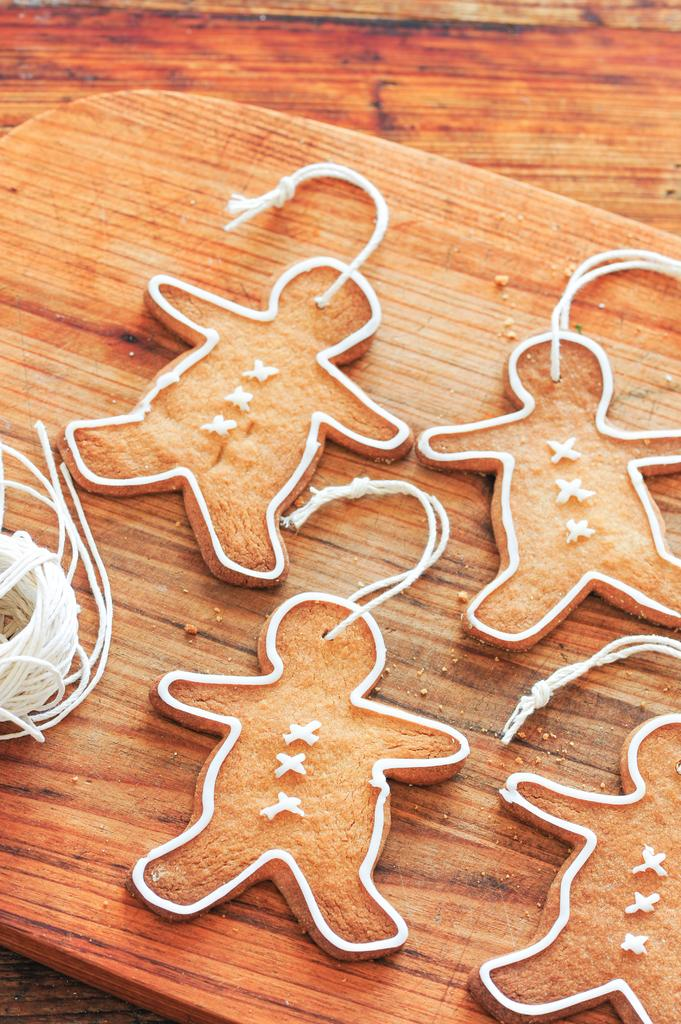What type of cookies are depicted in the image? There are human-shaped cookies in the image. How are the cookies arranged or positioned? The cookies are placed on a board. What year was the lumber used to make the board in the image? There is no information about the year or the lumber used to make the board in the image. 